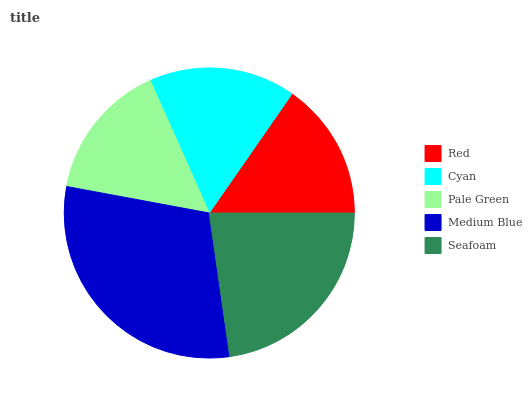Is Red the minimum?
Answer yes or no. Yes. Is Medium Blue the maximum?
Answer yes or no. Yes. Is Cyan the minimum?
Answer yes or no. No. Is Cyan the maximum?
Answer yes or no. No. Is Cyan greater than Red?
Answer yes or no. Yes. Is Red less than Cyan?
Answer yes or no. Yes. Is Red greater than Cyan?
Answer yes or no. No. Is Cyan less than Red?
Answer yes or no. No. Is Cyan the high median?
Answer yes or no. Yes. Is Cyan the low median?
Answer yes or no. Yes. Is Pale Green the high median?
Answer yes or no. No. Is Red the low median?
Answer yes or no. No. 